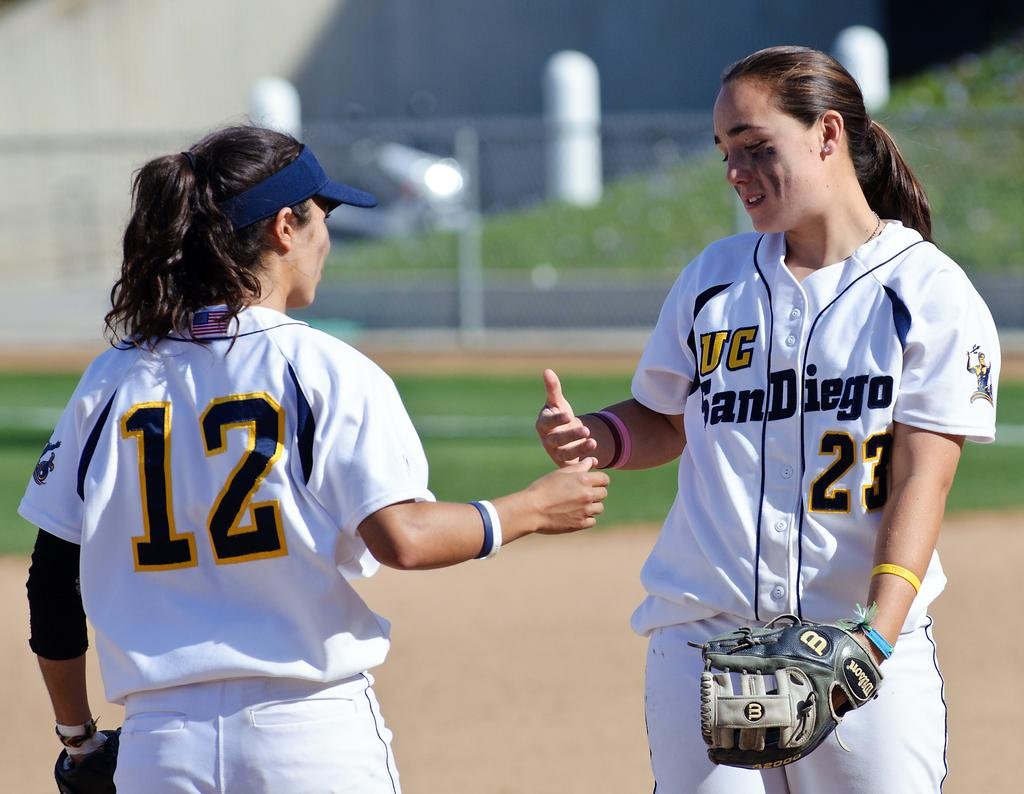<image>
Give a short and clear explanation of the subsequent image. the city of san diego is on the shirts 